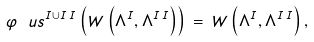<formula> <loc_0><loc_0><loc_500><loc_500>\varphi _ { \ } u s ^ { I \cup I \, I } \left ( W \left ( \Lambda ^ { I } , \Lambda ^ { I \, I } \right ) \right ) \, = \, W \left ( \Lambda ^ { I } , \Lambda ^ { I \, I } \right ) ,</formula> 